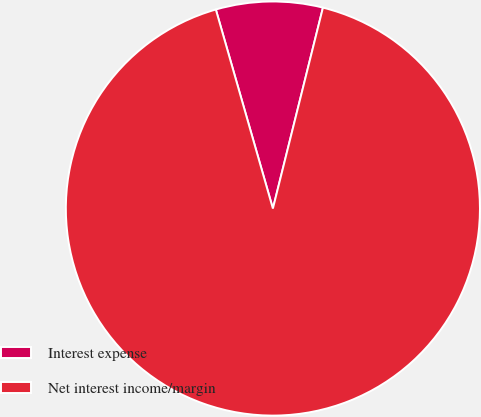Convert chart. <chart><loc_0><loc_0><loc_500><loc_500><pie_chart><fcel>Interest expense<fcel>Net interest income/margin<nl><fcel>8.33%<fcel>91.67%<nl></chart> 